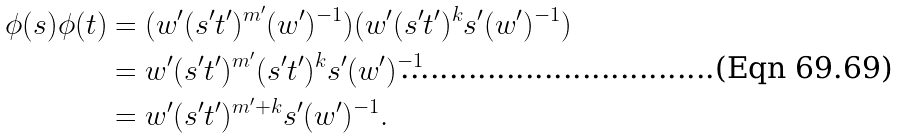<formula> <loc_0><loc_0><loc_500><loc_500>\phi ( s ) \phi ( t ) & = ( w ^ { \prime } ( s ^ { \prime } t ^ { \prime } ) ^ { m ^ { \prime } } ( w ^ { \prime } ) ^ { - 1 } ) ( w ^ { \prime } ( s ^ { \prime } t ^ { \prime } ) ^ { k } s ^ { \prime } ( w ^ { \prime } ) ^ { - 1 } ) \\ & = w ^ { \prime } ( s ^ { \prime } t ^ { \prime } ) ^ { m ^ { \prime } } ( s ^ { \prime } t ^ { \prime } ) ^ { k } s ^ { \prime } ( w ^ { \prime } ) ^ { - 1 } \\ & = w ^ { \prime } ( s ^ { \prime } t ^ { \prime } ) ^ { m ^ { \prime } + k } s ^ { \prime } ( w ^ { \prime } ) ^ { - 1 } .</formula> 